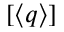Convert formula to latex. <formula><loc_0><loc_0><loc_500><loc_500>[ \langle q \rangle ]</formula> 